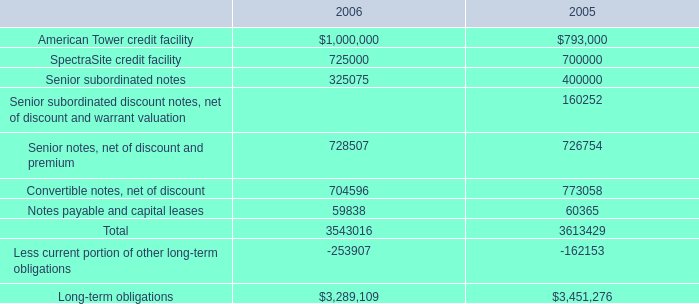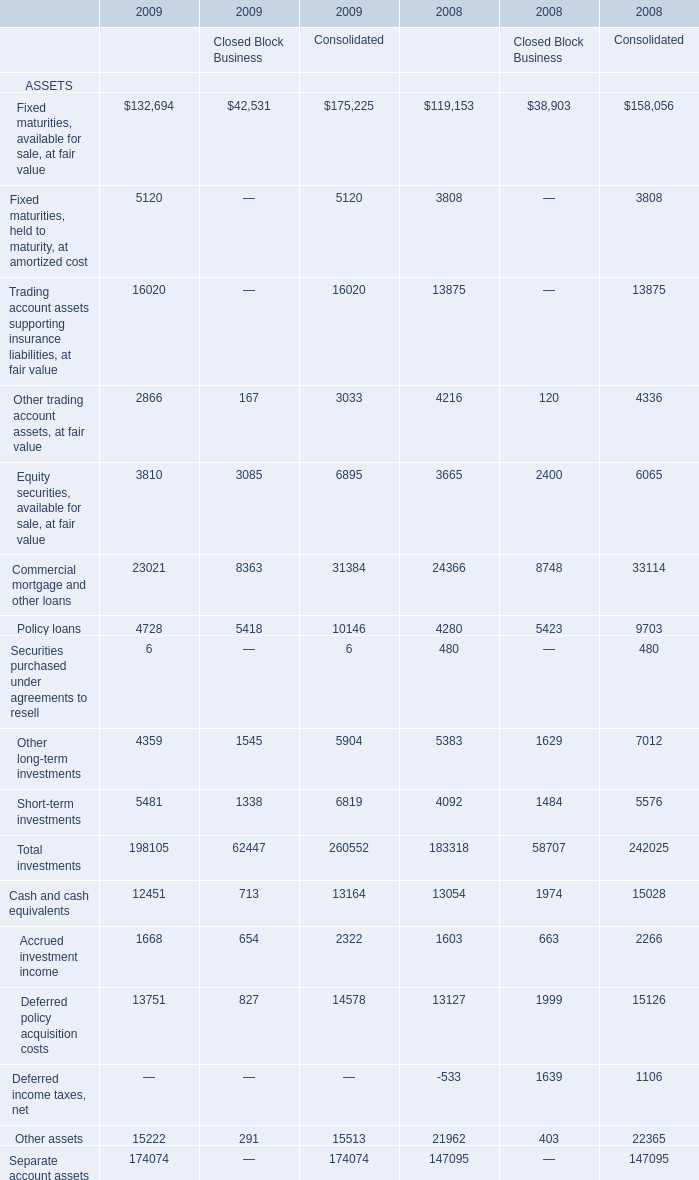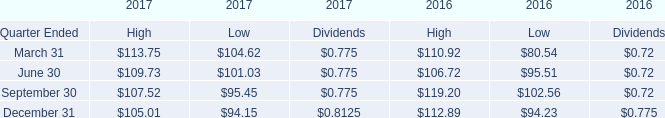What is the average amount of American Tower credit facility of 2005, and TOTAL ASSETS of 2008 Closed Block Business ? 
Computations: ((793000.0 + 65385.0) / 2)
Answer: 429192.5. 